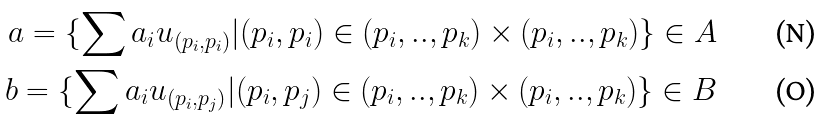<formula> <loc_0><loc_0><loc_500><loc_500>a = \{ \sum a _ { i } u _ { ( p _ { i } , p _ { i } ) } | ( p _ { i } , p _ { i } ) \in ( p _ { i } , . . , p _ { k } ) \times ( p _ { i } , . . , p _ { k } ) \} \in A \\ b = \{ \sum a _ { i } u _ { ( p _ { i } , p _ { j } ) } | ( p _ { i } , p _ { j } ) \in ( p _ { i } , . . , p _ { k } ) \times ( p _ { i } , . . , p _ { k } ) \} \in B</formula> 